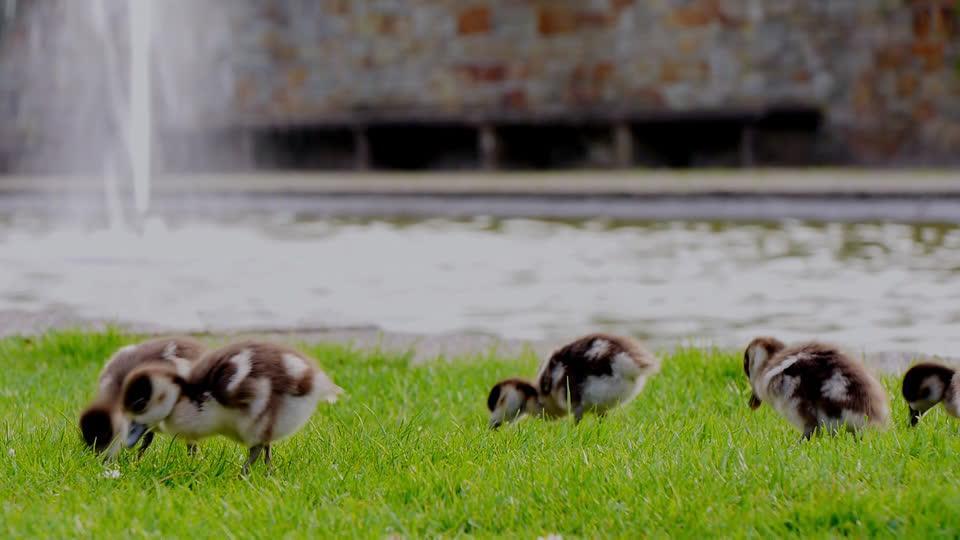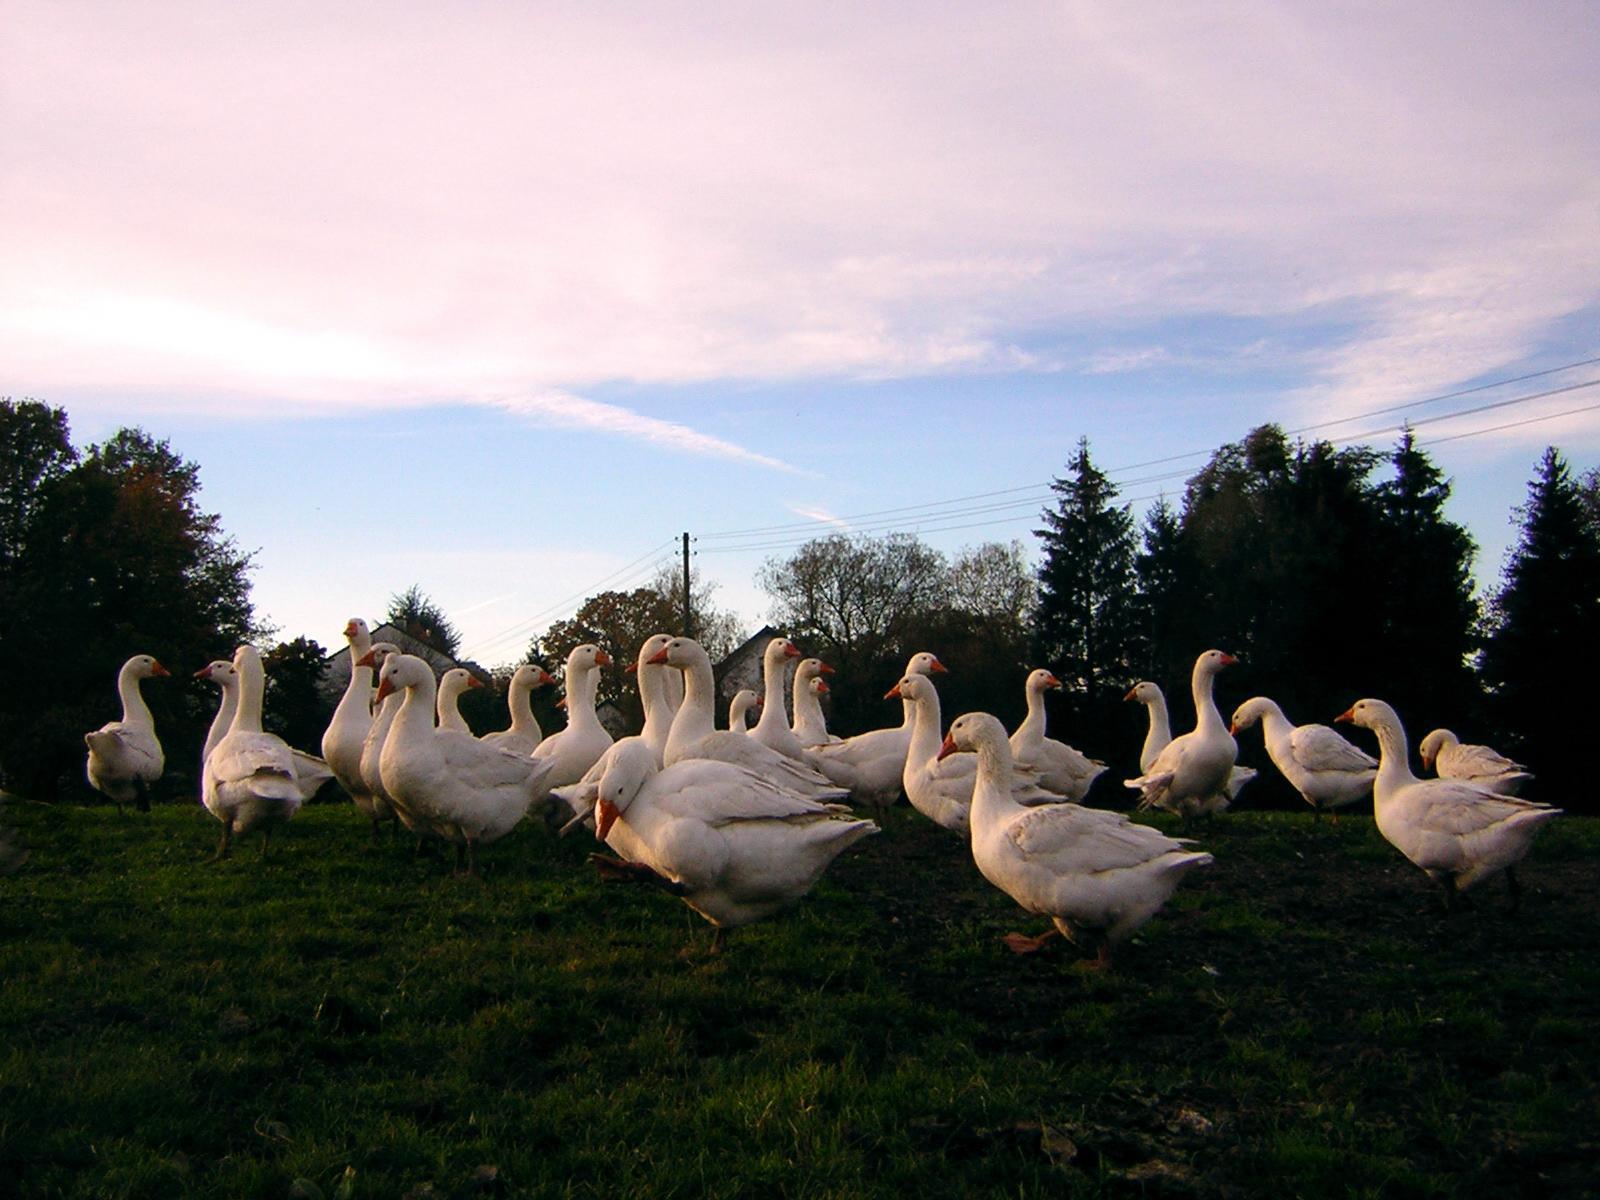The first image is the image on the left, the second image is the image on the right. Assess this claim about the two images: "An image shows a man holding out some type of stick while standing on a green field behind ducks.". Correct or not? Answer yes or no. No. The first image is the image on the left, the second image is the image on the right. For the images shown, is this caption "One of the images shows a person holding a stick." true? Answer yes or no. No. 